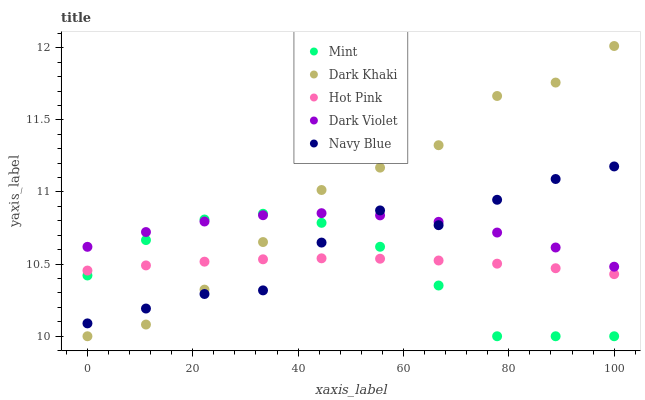Does Mint have the minimum area under the curve?
Answer yes or no. Yes. Does Dark Khaki have the maximum area under the curve?
Answer yes or no. Yes. Does Navy Blue have the minimum area under the curve?
Answer yes or no. No. Does Navy Blue have the maximum area under the curve?
Answer yes or no. No. Is Hot Pink the smoothest?
Answer yes or no. Yes. Is Navy Blue the roughest?
Answer yes or no. Yes. Is Navy Blue the smoothest?
Answer yes or no. No. Is Hot Pink the roughest?
Answer yes or no. No. Does Dark Khaki have the lowest value?
Answer yes or no. Yes. Does Navy Blue have the lowest value?
Answer yes or no. No. Does Dark Khaki have the highest value?
Answer yes or no. Yes. Does Navy Blue have the highest value?
Answer yes or no. No. Is Hot Pink less than Dark Violet?
Answer yes or no. Yes. Is Dark Violet greater than Hot Pink?
Answer yes or no. Yes. Does Navy Blue intersect Mint?
Answer yes or no. Yes. Is Navy Blue less than Mint?
Answer yes or no. No. Is Navy Blue greater than Mint?
Answer yes or no. No. Does Hot Pink intersect Dark Violet?
Answer yes or no. No. 